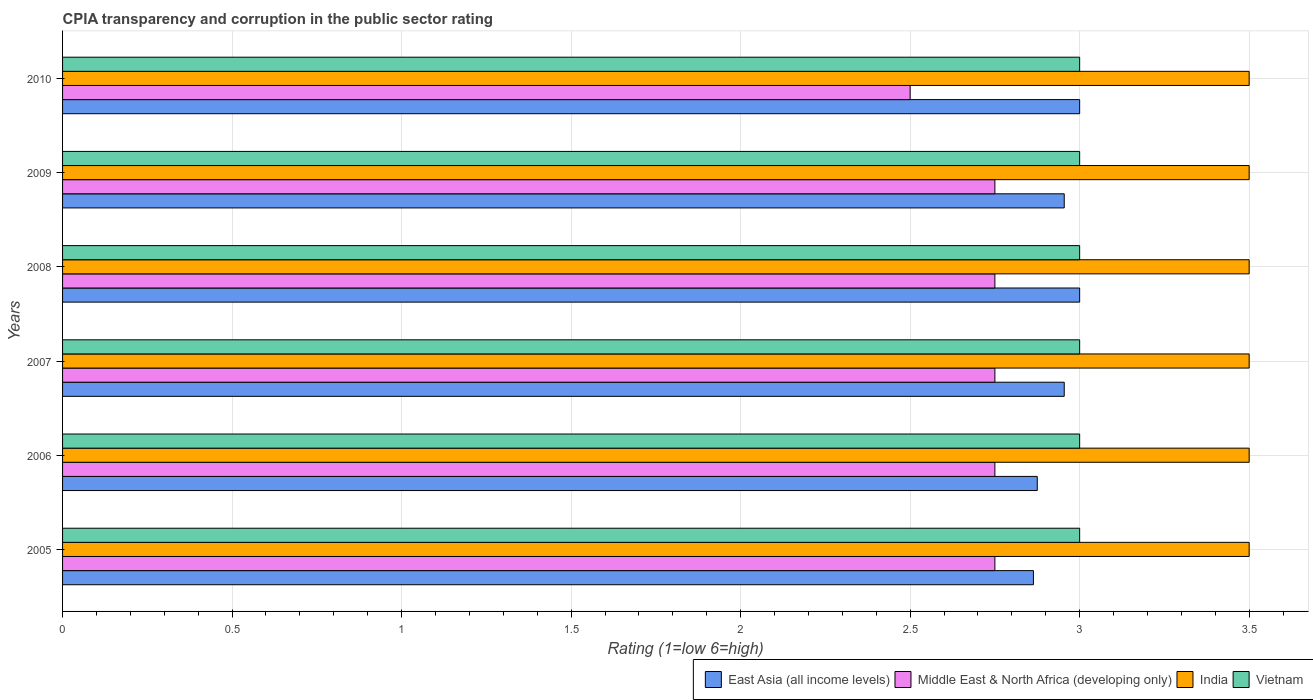How many groups of bars are there?
Your answer should be compact. 6. How many bars are there on the 2nd tick from the top?
Provide a succinct answer. 4. What is the label of the 3rd group of bars from the top?
Provide a short and direct response. 2008. Across all years, what is the minimum CPIA rating in India?
Your answer should be very brief. 3.5. In which year was the CPIA rating in Vietnam maximum?
Provide a short and direct response. 2005. What is the total CPIA rating in Vietnam in the graph?
Offer a very short reply. 18. What is the difference between the CPIA rating in Vietnam in 2007 and that in 2009?
Your response must be concise. 0. In the year 2008, what is the difference between the CPIA rating in East Asia (all income levels) and CPIA rating in Vietnam?
Offer a very short reply. 0. What is the ratio of the CPIA rating in India in 2007 to that in 2009?
Keep it short and to the point. 1. Is the CPIA rating in Middle East & North Africa (developing only) in 2005 less than that in 2010?
Offer a terse response. No. Is the difference between the CPIA rating in East Asia (all income levels) in 2007 and 2010 greater than the difference between the CPIA rating in Vietnam in 2007 and 2010?
Offer a terse response. No. What is the difference between the highest and the second highest CPIA rating in East Asia (all income levels)?
Your answer should be compact. 0. What is the difference between the highest and the lowest CPIA rating in Vietnam?
Provide a succinct answer. 0. In how many years, is the CPIA rating in East Asia (all income levels) greater than the average CPIA rating in East Asia (all income levels) taken over all years?
Your answer should be compact. 4. What does the 4th bar from the top in 2006 represents?
Give a very brief answer. East Asia (all income levels). What does the 3rd bar from the bottom in 2009 represents?
Your response must be concise. India. Is it the case that in every year, the sum of the CPIA rating in Vietnam and CPIA rating in India is greater than the CPIA rating in Middle East & North Africa (developing only)?
Offer a terse response. Yes. Are the values on the major ticks of X-axis written in scientific E-notation?
Your answer should be very brief. No. How are the legend labels stacked?
Keep it short and to the point. Horizontal. What is the title of the graph?
Provide a succinct answer. CPIA transparency and corruption in the public sector rating. What is the label or title of the X-axis?
Your answer should be compact. Rating (1=low 6=high). What is the label or title of the Y-axis?
Your response must be concise. Years. What is the Rating (1=low 6=high) in East Asia (all income levels) in 2005?
Ensure brevity in your answer.  2.86. What is the Rating (1=low 6=high) of Middle East & North Africa (developing only) in 2005?
Keep it short and to the point. 2.75. What is the Rating (1=low 6=high) in India in 2005?
Offer a very short reply. 3.5. What is the Rating (1=low 6=high) in Vietnam in 2005?
Keep it short and to the point. 3. What is the Rating (1=low 6=high) in East Asia (all income levels) in 2006?
Your answer should be very brief. 2.88. What is the Rating (1=low 6=high) in Middle East & North Africa (developing only) in 2006?
Your response must be concise. 2.75. What is the Rating (1=low 6=high) in India in 2006?
Give a very brief answer. 3.5. What is the Rating (1=low 6=high) of East Asia (all income levels) in 2007?
Offer a terse response. 2.95. What is the Rating (1=low 6=high) in Middle East & North Africa (developing only) in 2007?
Make the answer very short. 2.75. What is the Rating (1=low 6=high) in India in 2007?
Keep it short and to the point. 3.5. What is the Rating (1=low 6=high) in Vietnam in 2007?
Your response must be concise. 3. What is the Rating (1=low 6=high) in Middle East & North Africa (developing only) in 2008?
Your answer should be very brief. 2.75. What is the Rating (1=low 6=high) in Vietnam in 2008?
Provide a short and direct response. 3. What is the Rating (1=low 6=high) of East Asia (all income levels) in 2009?
Offer a very short reply. 2.95. What is the Rating (1=low 6=high) of Middle East & North Africa (developing only) in 2009?
Keep it short and to the point. 2.75. What is the Rating (1=low 6=high) in India in 2009?
Keep it short and to the point. 3.5. What is the Rating (1=low 6=high) of East Asia (all income levels) in 2010?
Make the answer very short. 3. What is the Rating (1=low 6=high) of Middle East & North Africa (developing only) in 2010?
Your response must be concise. 2.5. Across all years, what is the maximum Rating (1=low 6=high) of East Asia (all income levels)?
Provide a succinct answer. 3. Across all years, what is the maximum Rating (1=low 6=high) in Middle East & North Africa (developing only)?
Your answer should be very brief. 2.75. Across all years, what is the maximum Rating (1=low 6=high) in Vietnam?
Offer a very short reply. 3. Across all years, what is the minimum Rating (1=low 6=high) of East Asia (all income levels)?
Your answer should be compact. 2.86. What is the total Rating (1=low 6=high) in East Asia (all income levels) in the graph?
Ensure brevity in your answer.  17.65. What is the total Rating (1=low 6=high) in Middle East & North Africa (developing only) in the graph?
Ensure brevity in your answer.  16.25. What is the difference between the Rating (1=low 6=high) in East Asia (all income levels) in 2005 and that in 2006?
Provide a short and direct response. -0.01. What is the difference between the Rating (1=low 6=high) in Middle East & North Africa (developing only) in 2005 and that in 2006?
Your response must be concise. 0. What is the difference between the Rating (1=low 6=high) in Vietnam in 2005 and that in 2006?
Provide a succinct answer. 0. What is the difference between the Rating (1=low 6=high) in East Asia (all income levels) in 2005 and that in 2007?
Your answer should be very brief. -0.09. What is the difference between the Rating (1=low 6=high) in Middle East & North Africa (developing only) in 2005 and that in 2007?
Offer a very short reply. 0. What is the difference between the Rating (1=low 6=high) of India in 2005 and that in 2007?
Your answer should be very brief. 0. What is the difference between the Rating (1=low 6=high) in Vietnam in 2005 and that in 2007?
Your response must be concise. 0. What is the difference between the Rating (1=low 6=high) in East Asia (all income levels) in 2005 and that in 2008?
Offer a very short reply. -0.14. What is the difference between the Rating (1=low 6=high) of Vietnam in 2005 and that in 2008?
Make the answer very short. 0. What is the difference between the Rating (1=low 6=high) of East Asia (all income levels) in 2005 and that in 2009?
Provide a short and direct response. -0.09. What is the difference between the Rating (1=low 6=high) of East Asia (all income levels) in 2005 and that in 2010?
Make the answer very short. -0.14. What is the difference between the Rating (1=low 6=high) in Middle East & North Africa (developing only) in 2005 and that in 2010?
Your answer should be compact. 0.25. What is the difference between the Rating (1=low 6=high) in East Asia (all income levels) in 2006 and that in 2007?
Keep it short and to the point. -0.08. What is the difference between the Rating (1=low 6=high) of Middle East & North Africa (developing only) in 2006 and that in 2007?
Give a very brief answer. 0. What is the difference between the Rating (1=low 6=high) of Vietnam in 2006 and that in 2007?
Make the answer very short. 0. What is the difference between the Rating (1=low 6=high) of East Asia (all income levels) in 2006 and that in 2008?
Provide a succinct answer. -0.12. What is the difference between the Rating (1=low 6=high) of Middle East & North Africa (developing only) in 2006 and that in 2008?
Your answer should be compact. 0. What is the difference between the Rating (1=low 6=high) of India in 2006 and that in 2008?
Your response must be concise. 0. What is the difference between the Rating (1=low 6=high) of East Asia (all income levels) in 2006 and that in 2009?
Provide a short and direct response. -0.08. What is the difference between the Rating (1=low 6=high) of Middle East & North Africa (developing only) in 2006 and that in 2009?
Your answer should be compact. 0. What is the difference between the Rating (1=low 6=high) in Vietnam in 2006 and that in 2009?
Your answer should be very brief. 0. What is the difference between the Rating (1=low 6=high) in East Asia (all income levels) in 2006 and that in 2010?
Provide a short and direct response. -0.12. What is the difference between the Rating (1=low 6=high) in Middle East & North Africa (developing only) in 2006 and that in 2010?
Provide a succinct answer. 0.25. What is the difference between the Rating (1=low 6=high) in India in 2006 and that in 2010?
Your response must be concise. 0. What is the difference between the Rating (1=low 6=high) of Vietnam in 2006 and that in 2010?
Provide a succinct answer. 0. What is the difference between the Rating (1=low 6=high) of East Asia (all income levels) in 2007 and that in 2008?
Provide a short and direct response. -0.05. What is the difference between the Rating (1=low 6=high) of India in 2007 and that in 2008?
Ensure brevity in your answer.  0. What is the difference between the Rating (1=low 6=high) of Middle East & North Africa (developing only) in 2007 and that in 2009?
Provide a succinct answer. 0. What is the difference between the Rating (1=low 6=high) of India in 2007 and that in 2009?
Keep it short and to the point. 0. What is the difference between the Rating (1=low 6=high) of Vietnam in 2007 and that in 2009?
Your answer should be compact. 0. What is the difference between the Rating (1=low 6=high) of East Asia (all income levels) in 2007 and that in 2010?
Your response must be concise. -0.05. What is the difference between the Rating (1=low 6=high) of Vietnam in 2007 and that in 2010?
Offer a terse response. 0. What is the difference between the Rating (1=low 6=high) in East Asia (all income levels) in 2008 and that in 2009?
Your answer should be very brief. 0.05. What is the difference between the Rating (1=low 6=high) of Middle East & North Africa (developing only) in 2008 and that in 2009?
Make the answer very short. 0. What is the difference between the Rating (1=low 6=high) in India in 2008 and that in 2009?
Your answer should be compact. 0. What is the difference between the Rating (1=low 6=high) of East Asia (all income levels) in 2008 and that in 2010?
Give a very brief answer. 0. What is the difference between the Rating (1=low 6=high) in East Asia (all income levels) in 2009 and that in 2010?
Ensure brevity in your answer.  -0.05. What is the difference between the Rating (1=low 6=high) of Middle East & North Africa (developing only) in 2009 and that in 2010?
Ensure brevity in your answer.  0.25. What is the difference between the Rating (1=low 6=high) of India in 2009 and that in 2010?
Your answer should be compact. 0. What is the difference between the Rating (1=low 6=high) of Vietnam in 2009 and that in 2010?
Provide a succinct answer. 0. What is the difference between the Rating (1=low 6=high) of East Asia (all income levels) in 2005 and the Rating (1=low 6=high) of Middle East & North Africa (developing only) in 2006?
Your answer should be very brief. 0.11. What is the difference between the Rating (1=low 6=high) in East Asia (all income levels) in 2005 and the Rating (1=low 6=high) in India in 2006?
Give a very brief answer. -0.64. What is the difference between the Rating (1=low 6=high) of East Asia (all income levels) in 2005 and the Rating (1=low 6=high) of Vietnam in 2006?
Your answer should be very brief. -0.14. What is the difference between the Rating (1=low 6=high) of Middle East & North Africa (developing only) in 2005 and the Rating (1=low 6=high) of India in 2006?
Give a very brief answer. -0.75. What is the difference between the Rating (1=low 6=high) in Middle East & North Africa (developing only) in 2005 and the Rating (1=low 6=high) in Vietnam in 2006?
Give a very brief answer. -0.25. What is the difference between the Rating (1=low 6=high) of India in 2005 and the Rating (1=low 6=high) of Vietnam in 2006?
Provide a succinct answer. 0.5. What is the difference between the Rating (1=low 6=high) in East Asia (all income levels) in 2005 and the Rating (1=low 6=high) in Middle East & North Africa (developing only) in 2007?
Ensure brevity in your answer.  0.11. What is the difference between the Rating (1=low 6=high) in East Asia (all income levels) in 2005 and the Rating (1=low 6=high) in India in 2007?
Ensure brevity in your answer.  -0.64. What is the difference between the Rating (1=low 6=high) in East Asia (all income levels) in 2005 and the Rating (1=low 6=high) in Vietnam in 2007?
Your answer should be very brief. -0.14. What is the difference between the Rating (1=low 6=high) of Middle East & North Africa (developing only) in 2005 and the Rating (1=low 6=high) of India in 2007?
Give a very brief answer. -0.75. What is the difference between the Rating (1=low 6=high) in East Asia (all income levels) in 2005 and the Rating (1=low 6=high) in Middle East & North Africa (developing only) in 2008?
Keep it short and to the point. 0.11. What is the difference between the Rating (1=low 6=high) of East Asia (all income levels) in 2005 and the Rating (1=low 6=high) of India in 2008?
Provide a short and direct response. -0.64. What is the difference between the Rating (1=low 6=high) in East Asia (all income levels) in 2005 and the Rating (1=low 6=high) in Vietnam in 2008?
Give a very brief answer. -0.14. What is the difference between the Rating (1=low 6=high) of Middle East & North Africa (developing only) in 2005 and the Rating (1=low 6=high) of India in 2008?
Offer a terse response. -0.75. What is the difference between the Rating (1=low 6=high) of East Asia (all income levels) in 2005 and the Rating (1=low 6=high) of Middle East & North Africa (developing only) in 2009?
Your answer should be compact. 0.11. What is the difference between the Rating (1=low 6=high) of East Asia (all income levels) in 2005 and the Rating (1=low 6=high) of India in 2009?
Your answer should be very brief. -0.64. What is the difference between the Rating (1=low 6=high) of East Asia (all income levels) in 2005 and the Rating (1=low 6=high) of Vietnam in 2009?
Offer a very short reply. -0.14. What is the difference between the Rating (1=low 6=high) of Middle East & North Africa (developing only) in 2005 and the Rating (1=low 6=high) of India in 2009?
Give a very brief answer. -0.75. What is the difference between the Rating (1=low 6=high) in Middle East & North Africa (developing only) in 2005 and the Rating (1=low 6=high) in Vietnam in 2009?
Offer a terse response. -0.25. What is the difference between the Rating (1=low 6=high) of India in 2005 and the Rating (1=low 6=high) of Vietnam in 2009?
Provide a short and direct response. 0.5. What is the difference between the Rating (1=low 6=high) of East Asia (all income levels) in 2005 and the Rating (1=low 6=high) of Middle East & North Africa (developing only) in 2010?
Your answer should be compact. 0.36. What is the difference between the Rating (1=low 6=high) of East Asia (all income levels) in 2005 and the Rating (1=low 6=high) of India in 2010?
Your response must be concise. -0.64. What is the difference between the Rating (1=low 6=high) of East Asia (all income levels) in 2005 and the Rating (1=low 6=high) of Vietnam in 2010?
Your response must be concise. -0.14. What is the difference between the Rating (1=low 6=high) of Middle East & North Africa (developing only) in 2005 and the Rating (1=low 6=high) of India in 2010?
Your answer should be compact. -0.75. What is the difference between the Rating (1=low 6=high) in India in 2005 and the Rating (1=low 6=high) in Vietnam in 2010?
Provide a short and direct response. 0.5. What is the difference between the Rating (1=low 6=high) of East Asia (all income levels) in 2006 and the Rating (1=low 6=high) of Middle East & North Africa (developing only) in 2007?
Your response must be concise. 0.12. What is the difference between the Rating (1=low 6=high) in East Asia (all income levels) in 2006 and the Rating (1=low 6=high) in India in 2007?
Give a very brief answer. -0.62. What is the difference between the Rating (1=low 6=high) in East Asia (all income levels) in 2006 and the Rating (1=low 6=high) in Vietnam in 2007?
Your answer should be very brief. -0.12. What is the difference between the Rating (1=low 6=high) in Middle East & North Africa (developing only) in 2006 and the Rating (1=low 6=high) in India in 2007?
Ensure brevity in your answer.  -0.75. What is the difference between the Rating (1=low 6=high) of Middle East & North Africa (developing only) in 2006 and the Rating (1=low 6=high) of Vietnam in 2007?
Make the answer very short. -0.25. What is the difference between the Rating (1=low 6=high) of India in 2006 and the Rating (1=low 6=high) of Vietnam in 2007?
Give a very brief answer. 0.5. What is the difference between the Rating (1=low 6=high) of East Asia (all income levels) in 2006 and the Rating (1=low 6=high) of India in 2008?
Offer a terse response. -0.62. What is the difference between the Rating (1=low 6=high) in East Asia (all income levels) in 2006 and the Rating (1=low 6=high) in Vietnam in 2008?
Offer a terse response. -0.12. What is the difference between the Rating (1=low 6=high) of Middle East & North Africa (developing only) in 2006 and the Rating (1=low 6=high) of India in 2008?
Give a very brief answer. -0.75. What is the difference between the Rating (1=low 6=high) in Middle East & North Africa (developing only) in 2006 and the Rating (1=low 6=high) in Vietnam in 2008?
Offer a very short reply. -0.25. What is the difference between the Rating (1=low 6=high) of India in 2006 and the Rating (1=low 6=high) of Vietnam in 2008?
Keep it short and to the point. 0.5. What is the difference between the Rating (1=low 6=high) of East Asia (all income levels) in 2006 and the Rating (1=low 6=high) of Middle East & North Africa (developing only) in 2009?
Your answer should be compact. 0.12. What is the difference between the Rating (1=low 6=high) in East Asia (all income levels) in 2006 and the Rating (1=low 6=high) in India in 2009?
Offer a very short reply. -0.62. What is the difference between the Rating (1=low 6=high) in East Asia (all income levels) in 2006 and the Rating (1=low 6=high) in Vietnam in 2009?
Your answer should be compact. -0.12. What is the difference between the Rating (1=low 6=high) in Middle East & North Africa (developing only) in 2006 and the Rating (1=low 6=high) in India in 2009?
Give a very brief answer. -0.75. What is the difference between the Rating (1=low 6=high) in East Asia (all income levels) in 2006 and the Rating (1=low 6=high) in India in 2010?
Your answer should be very brief. -0.62. What is the difference between the Rating (1=low 6=high) in East Asia (all income levels) in 2006 and the Rating (1=low 6=high) in Vietnam in 2010?
Ensure brevity in your answer.  -0.12. What is the difference between the Rating (1=low 6=high) in Middle East & North Africa (developing only) in 2006 and the Rating (1=low 6=high) in India in 2010?
Ensure brevity in your answer.  -0.75. What is the difference between the Rating (1=low 6=high) of Middle East & North Africa (developing only) in 2006 and the Rating (1=low 6=high) of Vietnam in 2010?
Your answer should be compact. -0.25. What is the difference between the Rating (1=low 6=high) of India in 2006 and the Rating (1=low 6=high) of Vietnam in 2010?
Offer a terse response. 0.5. What is the difference between the Rating (1=low 6=high) of East Asia (all income levels) in 2007 and the Rating (1=low 6=high) of Middle East & North Africa (developing only) in 2008?
Provide a succinct answer. 0.2. What is the difference between the Rating (1=low 6=high) in East Asia (all income levels) in 2007 and the Rating (1=low 6=high) in India in 2008?
Ensure brevity in your answer.  -0.55. What is the difference between the Rating (1=low 6=high) in East Asia (all income levels) in 2007 and the Rating (1=low 6=high) in Vietnam in 2008?
Your answer should be very brief. -0.05. What is the difference between the Rating (1=low 6=high) in Middle East & North Africa (developing only) in 2007 and the Rating (1=low 6=high) in India in 2008?
Offer a terse response. -0.75. What is the difference between the Rating (1=low 6=high) of Middle East & North Africa (developing only) in 2007 and the Rating (1=low 6=high) of Vietnam in 2008?
Provide a succinct answer. -0.25. What is the difference between the Rating (1=low 6=high) in India in 2007 and the Rating (1=low 6=high) in Vietnam in 2008?
Ensure brevity in your answer.  0.5. What is the difference between the Rating (1=low 6=high) in East Asia (all income levels) in 2007 and the Rating (1=low 6=high) in Middle East & North Africa (developing only) in 2009?
Provide a succinct answer. 0.2. What is the difference between the Rating (1=low 6=high) of East Asia (all income levels) in 2007 and the Rating (1=low 6=high) of India in 2009?
Provide a succinct answer. -0.55. What is the difference between the Rating (1=low 6=high) of East Asia (all income levels) in 2007 and the Rating (1=low 6=high) of Vietnam in 2009?
Make the answer very short. -0.05. What is the difference between the Rating (1=low 6=high) of Middle East & North Africa (developing only) in 2007 and the Rating (1=low 6=high) of India in 2009?
Ensure brevity in your answer.  -0.75. What is the difference between the Rating (1=low 6=high) of East Asia (all income levels) in 2007 and the Rating (1=low 6=high) of Middle East & North Africa (developing only) in 2010?
Ensure brevity in your answer.  0.45. What is the difference between the Rating (1=low 6=high) of East Asia (all income levels) in 2007 and the Rating (1=low 6=high) of India in 2010?
Make the answer very short. -0.55. What is the difference between the Rating (1=low 6=high) in East Asia (all income levels) in 2007 and the Rating (1=low 6=high) in Vietnam in 2010?
Offer a terse response. -0.05. What is the difference between the Rating (1=low 6=high) of Middle East & North Africa (developing only) in 2007 and the Rating (1=low 6=high) of India in 2010?
Your response must be concise. -0.75. What is the difference between the Rating (1=low 6=high) of Middle East & North Africa (developing only) in 2007 and the Rating (1=low 6=high) of Vietnam in 2010?
Your answer should be very brief. -0.25. What is the difference between the Rating (1=low 6=high) in East Asia (all income levels) in 2008 and the Rating (1=low 6=high) in Vietnam in 2009?
Offer a very short reply. 0. What is the difference between the Rating (1=low 6=high) in Middle East & North Africa (developing only) in 2008 and the Rating (1=low 6=high) in India in 2009?
Your answer should be very brief. -0.75. What is the difference between the Rating (1=low 6=high) in Middle East & North Africa (developing only) in 2008 and the Rating (1=low 6=high) in Vietnam in 2009?
Your answer should be very brief. -0.25. What is the difference between the Rating (1=low 6=high) in India in 2008 and the Rating (1=low 6=high) in Vietnam in 2009?
Offer a terse response. 0.5. What is the difference between the Rating (1=low 6=high) of East Asia (all income levels) in 2008 and the Rating (1=low 6=high) of India in 2010?
Your response must be concise. -0.5. What is the difference between the Rating (1=low 6=high) in East Asia (all income levels) in 2008 and the Rating (1=low 6=high) in Vietnam in 2010?
Offer a terse response. 0. What is the difference between the Rating (1=low 6=high) of Middle East & North Africa (developing only) in 2008 and the Rating (1=low 6=high) of India in 2010?
Keep it short and to the point. -0.75. What is the difference between the Rating (1=low 6=high) of Middle East & North Africa (developing only) in 2008 and the Rating (1=low 6=high) of Vietnam in 2010?
Your answer should be compact. -0.25. What is the difference between the Rating (1=low 6=high) in India in 2008 and the Rating (1=low 6=high) in Vietnam in 2010?
Give a very brief answer. 0.5. What is the difference between the Rating (1=low 6=high) of East Asia (all income levels) in 2009 and the Rating (1=low 6=high) of Middle East & North Africa (developing only) in 2010?
Provide a short and direct response. 0.45. What is the difference between the Rating (1=low 6=high) of East Asia (all income levels) in 2009 and the Rating (1=low 6=high) of India in 2010?
Keep it short and to the point. -0.55. What is the difference between the Rating (1=low 6=high) of East Asia (all income levels) in 2009 and the Rating (1=low 6=high) of Vietnam in 2010?
Your answer should be compact. -0.05. What is the difference between the Rating (1=low 6=high) in Middle East & North Africa (developing only) in 2009 and the Rating (1=low 6=high) in India in 2010?
Make the answer very short. -0.75. What is the difference between the Rating (1=low 6=high) in Middle East & North Africa (developing only) in 2009 and the Rating (1=low 6=high) in Vietnam in 2010?
Provide a short and direct response. -0.25. What is the difference between the Rating (1=low 6=high) of India in 2009 and the Rating (1=low 6=high) of Vietnam in 2010?
Provide a short and direct response. 0.5. What is the average Rating (1=low 6=high) of East Asia (all income levels) per year?
Provide a short and direct response. 2.94. What is the average Rating (1=low 6=high) in Middle East & North Africa (developing only) per year?
Your response must be concise. 2.71. In the year 2005, what is the difference between the Rating (1=low 6=high) of East Asia (all income levels) and Rating (1=low 6=high) of Middle East & North Africa (developing only)?
Your response must be concise. 0.11. In the year 2005, what is the difference between the Rating (1=low 6=high) in East Asia (all income levels) and Rating (1=low 6=high) in India?
Give a very brief answer. -0.64. In the year 2005, what is the difference between the Rating (1=low 6=high) of East Asia (all income levels) and Rating (1=low 6=high) of Vietnam?
Offer a very short reply. -0.14. In the year 2005, what is the difference between the Rating (1=low 6=high) of Middle East & North Africa (developing only) and Rating (1=low 6=high) of India?
Give a very brief answer. -0.75. In the year 2005, what is the difference between the Rating (1=low 6=high) of India and Rating (1=low 6=high) of Vietnam?
Give a very brief answer. 0.5. In the year 2006, what is the difference between the Rating (1=low 6=high) of East Asia (all income levels) and Rating (1=low 6=high) of India?
Ensure brevity in your answer.  -0.62. In the year 2006, what is the difference between the Rating (1=low 6=high) in East Asia (all income levels) and Rating (1=low 6=high) in Vietnam?
Your answer should be very brief. -0.12. In the year 2006, what is the difference between the Rating (1=low 6=high) in Middle East & North Africa (developing only) and Rating (1=low 6=high) in India?
Your answer should be compact. -0.75. In the year 2006, what is the difference between the Rating (1=low 6=high) in India and Rating (1=low 6=high) in Vietnam?
Offer a terse response. 0.5. In the year 2007, what is the difference between the Rating (1=low 6=high) in East Asia (all income levels) and Rating (1=low 6=high) in Middle East & North Africa (developing only)?
Keep it short and to the point. 0.2. In the year 2007, what is the difference between the Rating (1=low 6=high) of East Asia (all income levels) and Rating (1=low 6=high) of India?
Keep it short and to the point. -0.55. In the year 2007, what is the difference between the Rating (1=low 6=high) in East Asia (all income levels) and Rating (1=low 6=high) in Vietnam?
Provide a succinct answer. -0.05. In the year 2007, what is the difference between the Rating (1=low 6=high) in Middle East & North Africa (developing only) and Rating (1=low 6=high) in India?
Offer a terse response. -0.75. In the year 2007, what is the difference between the Rating (1=low 6=high) in India and Rating (1=low 6=high) in Vietnam?
Offer a very short reply. 0.5. In the year 2008, what is the difference between the Rating (1=low 6=high) in East Asia (all income levels) and Rating (1=low 6=high) in India?
Provide a succinct answer. -0.5. In the year 2008, what is the difference between the Rating (1=low 6=high) in East Asia (all income levels) and Rating (1=low 6=high) in Vietnam?
Offer a very short reply. 0. In the year 2008, what is the difference between the Rating (1=low 6=high) in Middle East & North Africa (developing only) and Rating (1=low 6=high) in India?
Make the answer very short. -0.75. In the year 2008, what is the difference between the Rating (1=low 6=high) of India and Rating (1=low 6=high) of Vietnam?
Give a very brief answer. 0.5. In the year 2009, what is the difference between the Rating (1=low 6=high) in East Asia (all income levels) and Rating (1=low 6=high) in Middle East & North Africa (developing only)?
Offer a terse response. 0.2. In the year 2009, what is the difference between the Rating (1=low 6=high) of East Asia (all income levels) and Rating (1=low 6=high) of India?
Offer a terse response. -0.55. In the year 2009, what is the difference between the Rating (1=low 6=high) in East Asia (all income levels) and Rating (1=low 6=high) in Vietnam?
Your answer should be compact. -0.05. In the year 2009, what is the difference between the Rating (1=low 6=high) of Middle East & North Africa (developing only) and Rating (1=low 6=high) of India?
Give a very brief answer. -0.75. In the year 2009, what is the difference between the Rating (1=low 6=high) in India and Rating (1=low 6=high) in Vietnam?
Provide a succinct answer. 0.5. In the year 2010, what is the difference between the Rating (1=low 6=high) of Middle East & North Africa (developing only) and Rating (1=low 6=high) of India?
Give a very brief answer. -1. In the year 2010, what is the difference between the Rating (1=low 6=high) of Middle East & North Africa (developing only) and Rating (1=low 6=high) of Vietnam?
Your answer should be very brief. -0.5. What is the ratio of the Rating (1=low 6=high) of Vietnam in 2005 to that in 2006?
Offer a terse response. 1. What is the ratio of the Rating (1=low 6=high) of East Asia (all income levels) in 2005 to that in 2007?
Your response must be concise. 0.97. What is the ratio of the Rating (1=low 6=high) in Middle East & North Africa (developing only) in 2005 to that in 2007?
Give a very brief answer. 1. What is the ratio of the Rating (1=low 6=high) of India in 2005 to that in 2007?
Your answer should be very brief. 1. What is the ratio of the Rating (1=low 6=high) of East Asia (all income levels) in 2005 to that in 2008?
Keep it short and to the point. 0.95. What is the ratio of the Rating (1=low 6=high) in East Asia (all income levels) in 2005 to that in 2009?
Offer a terse response. 0.97. What is the ratio of the Rating (1=low 6=high) in East Asia (all income levels) in 2005 to that in 2010?
Give a very brief answer. 0.95. What is the ratio of the Rating (1=low 6=high) in Middle East & North Africa (developing only) in 2005 to that in 2010?
Provide a succinct answer. 1.1. What is the ratio of the Rating (1=low 6=high) of Vietnam in 2005 to that in 2010?
Offer a very short reply. 1. What is the ratio of the Rating (1=low 6=high) in East Asia (all income levels) in 2006 to that in 2007?
Your response must be concise. 0.97. What is the ratio of the Rating (1=low 6=high) of India in 2006 to that in 2007?
Make the answer very short. 1. What is the ratio of the Rating (1=low 6=high) of Middle East & North Africa (developing only) in 2006 to that in 2008?
Provide a succinct answer. 1. What is the ratio of the Rating (1=low 6=high) of India in 2006 to that in 2008?
Ensure brevity in your answer.  1. What is the ratio of the Rating (1=low 6=high) of Vietnam in 2006 to that in 2008?
Ensure brevity in your answer.  1. What is the ratio of the Rating (1=low 6=high) of East Asia (all income levels) in 2006 to that in 2009?
Keep it short and to the point. 0.97. What is the ratio of the Rating (1=low 6=high) in Middle East & North Africa (developing only) in 2006 to that in 2009?
Your response must be concise. 1. What is the ratio of the Rating (1=low 6=high) in India in 2006 to that in 2009?
Your answer should be compact. 1. What is the ratio of the Rating (1=low 6=high) in Middle East & North Africa (developing only) in 2006 to that in 2010?
Provide a short and direct response. 1.1. What is the ratio of the Rating (1=low 6=high) in India in 2006 to that in 2010?
Offer a terse response. 1. What is the ratio of the Rating (1=low 6=high) in East Asia (all income levels) in 2007 to that in 2008?
Give a very brief answer. 0.98. What is the ratio of the Rating (1=low 6=high) of Middle East & North Africa (developing only) in 2007 to that in 2008?
Make the answer very short. 1. What is the ratio of the Rating (1=low 6=high) in India in 2007 to that in 2008?
Offer a terse response. 1. What is the ratio of the Rating (1=low 6=high) of Vietnam in 2007 to that in 2008?
Offer a very short reply. 1. What is the ratio of the Rating (1=low 6=high) of East Asia (all income levels) in 2007 to that in 2009?
Ensure brevity in your answer.  1. What is the ratio of the Rating (1=low 6=high) of Vietnam in 2007 to that in 2009?
Offer a very short reply. 1. What is the ratio of the Rating (1=low 6=high) in East Asia (all income levels) in 2007 to that in 2010?
Provide a succinct answer. 0.98. What is the ratio of the Rating (1=low 6=high) of Middle East & North Africa (developing only) in 2007 to that in 2010?
Offer a very short reply. 1.1. What is the ratio of the Rating (1=low 6=high) of Vietnam in 2007 to that in 2010?
Provide a succinct answer. 1. What is the ratio of the Rating (1=low 6=high) of East Asia (all income levels) in 2008 to that in 2009?
Keep it short and to the point. 1.02. What is the ratio of the Rating (1=low 6=high) in Middle East & North Africa (developing only) in 2008 to that in 2009?
Keep it short and to the point. 1. What is the ratio of the Rating (1=low 6=high) of Middle East & North Africa (developing only) in 2008 to that in 2010?
Make the answer very short. 1.1. What is the ratio of the Rating (1=low 6=high) in East Asia (all income levels) in 2009 to that in 2010?
Your answer should be very brief. 0.98. What is the ratio of the Rating (1=low 6=high) in Middle East & North Africa (developing only) in 2009 to that in 2010?
Make the answer very short. 1.1. What is the difference between the highest and the second highest Rating (1=low 6=high) in Middle East & North Africa (developing only)?
Offer a terse response. 0. What is the difference between the highest and the second highest Rating (1=low 6=high) in India?
Provide a succinct answer. 0. What is the difference between the highest and the second highest Rating (1=low 6=high) in Vietnam?
Your answer should be very brief. 0. What is the difference between the highest and the lowest Rating (1=low 6=high) of East Asia (all income levels)?
Offer a very short reply. 0.14. 